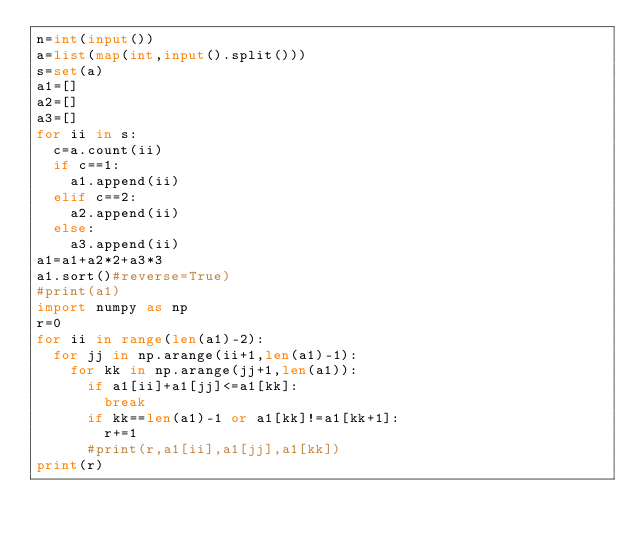<code> <loc_0><loc_0><loc_500><loc_500><_Python_>n=int(input())
a=list(map(int,input().split()))
s=set(a)
a1=[]
a2=[]
a3=[]
for ii in s:
  c=a.count(ii)
  if c==1:
    a1.append(ii)
  elif c==2:
    a2.append(ii)
  else:
    a3.append(ii)
a1=a1+a2*2+a3*3
a1.sort()#reverse=True)
#print(a1)
import numpy as np
r=0
for ii in range(len(a1)-2):
  for jj in np.arange(ii+1,len(a1)-1):
    for kk in np.arange(jj+1,len(a1)):
      if a1[ii]+a1[jj]<=a1[kk]:
        break
      if kk==len(a1)-1 or a1[kk]!=a1[kk+1]:
        r+=1
      #print(r,a1[ii],a1[jj],a1[kk])
print(r)
</code> 